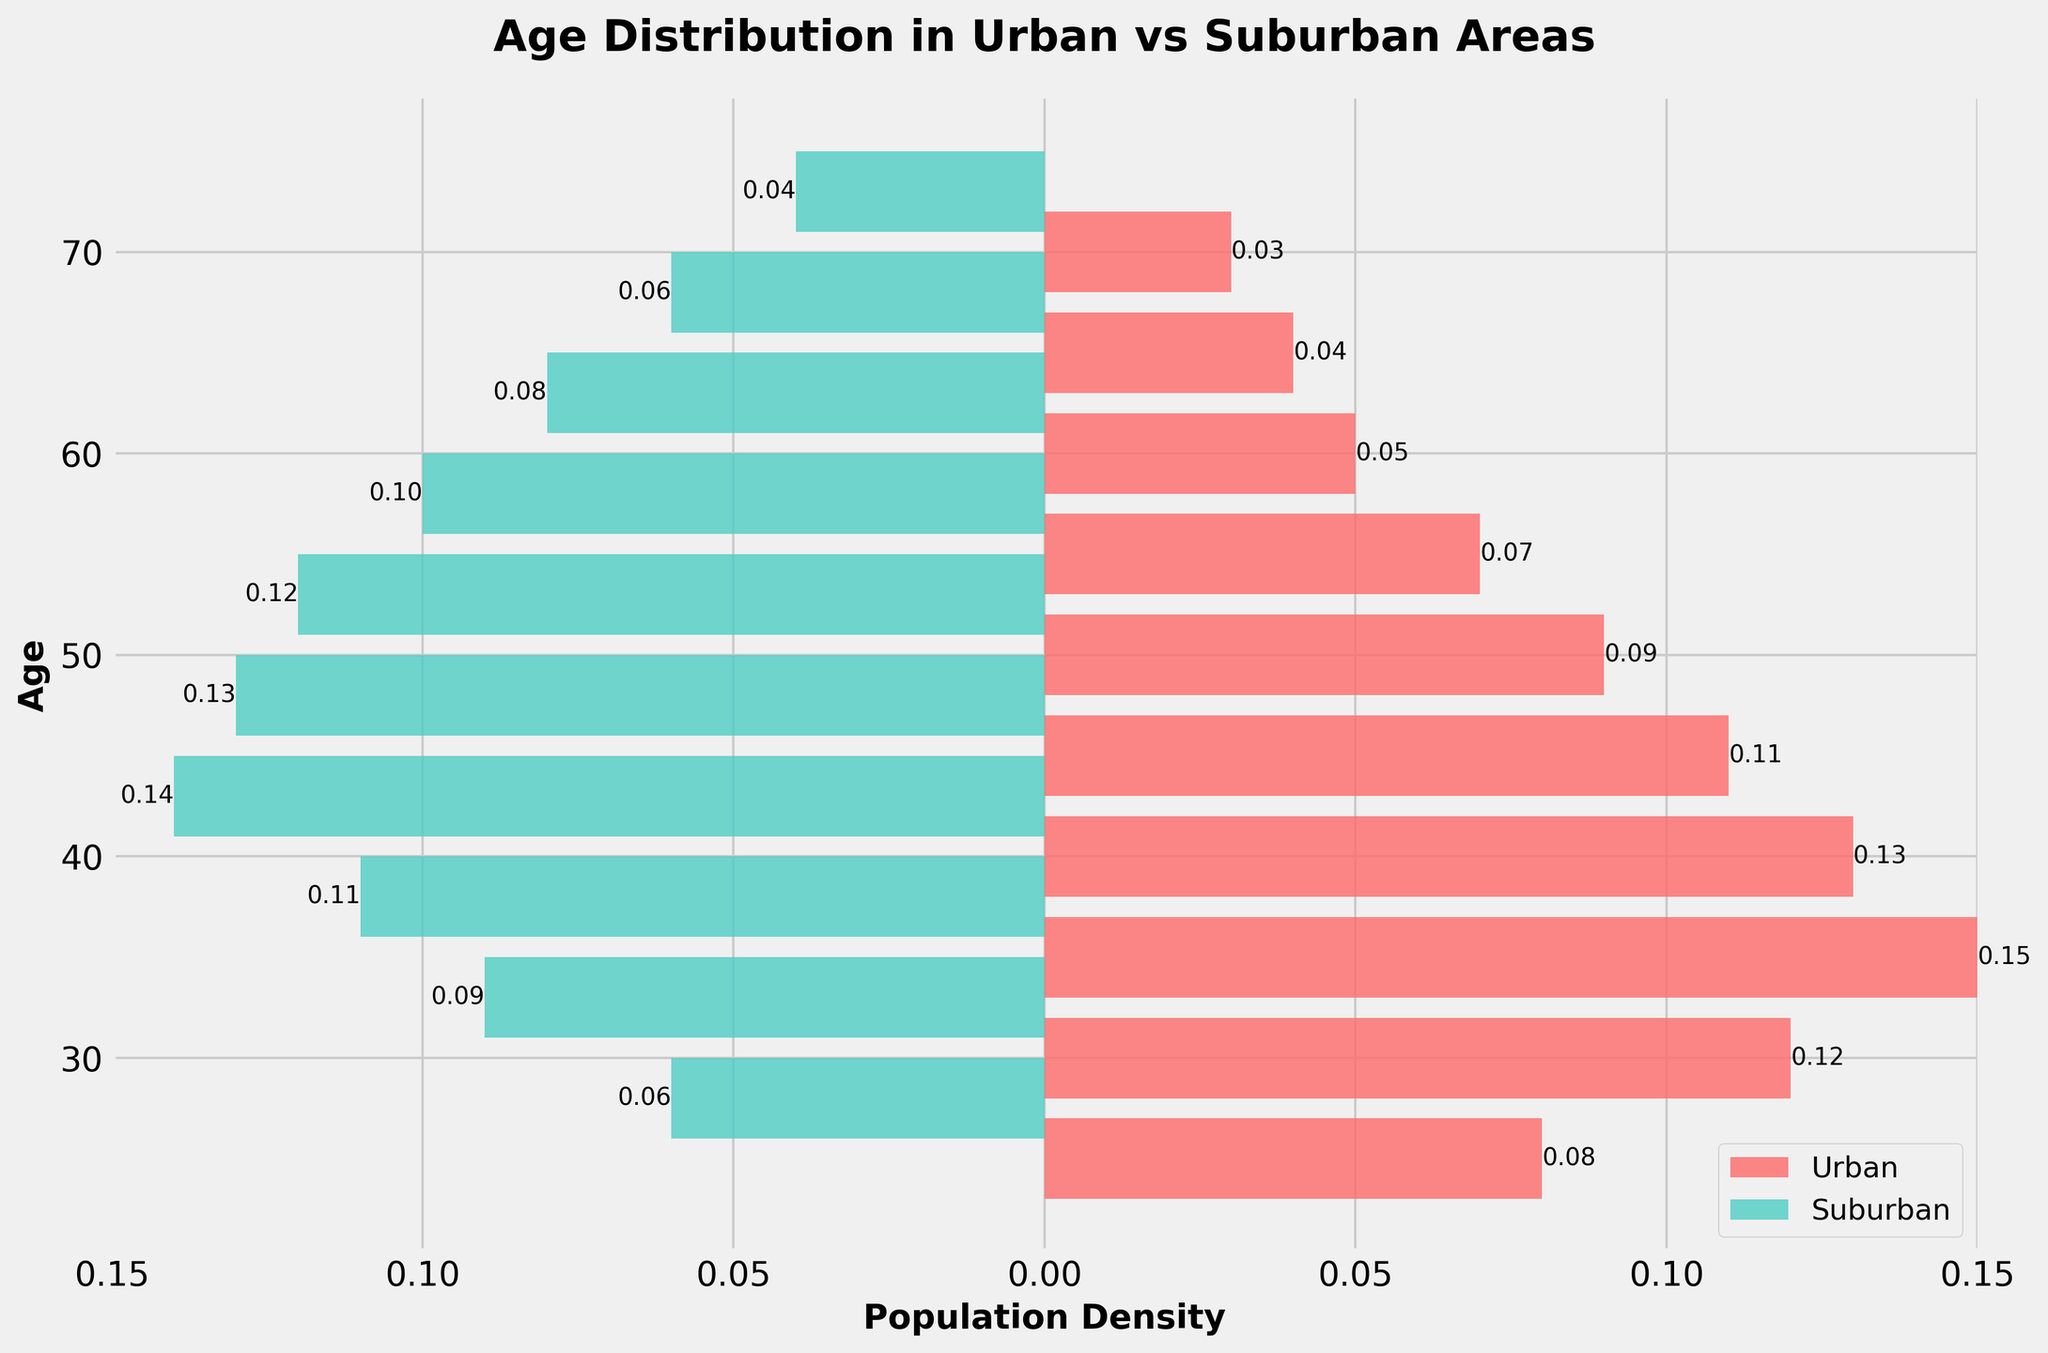What is the title of the figure? The title is usually displayed at the top of the figure and helps identify the main topic. By reading the text in the title area, you can see it says "Age Distribution in Urban vs Suburban Areas"
Answer: Age Distribution in Urban vs Suburban Areas How is the density for suburban areas represented in the plot? Suburban densities are depicted as horizontal bars extending to the left of the centerline. These bars are color-coded in a teal color and have negative density values on the left side
Answer: Horizontal bars in teal extending left At what age is the population density highest in urban areas? The highest bar for the urban area has the greatest horizontal length. By comparing the lengths, the bar at age 35 has the highest density value of 0.15
Answer: Age 35 Which area has a higher density at age 40, urban or suburban? Locate the horizontal bars for age 40 in both colors. Compare the lengths: Urban at age 40 has a bar extending 0.13 to the right, while Suburban at a similar age has a bar extending 0.14 to the left, indicating suburban is higher
Answer: Suburban What is the age range where suburban population density exceeds urban population density? Examine the horizontal lengths of bars for suburban and urban areas across different ages. Suburban density exceeds urban for ages 43 to 58 because the teal bars extend further left than the red bars extend right at those ages
Answer: 43 to 58 At age 65, how do the population densities compare between urban and suburban areas? Look at the bars corresponding to age 65. The urban density bar has a length of 0.04 extending to the right, while the suburban density bar for the same age is shorter at 0.04 extending to the left
Answer: Same What is the sum of the population densities at ages 35 and 40 in urban areas? Locate the bars for ages 35 and 40. At age 35, the density is 0.15, and at age 40, it is 0.13. The sum of these densities is 0.15 + 0.13 = 0.28
Answer: 0.28 Which age group has the lowest urban population density and what is the value? Identify the shortest bar in the urban area color. The shortest bar is at age 70 with a density value of 0.03
Answer: Age 70, 0.03 What is the average population density for suburban residents aged between 48 and 58? Measure the bars for ages 48, 53, and 58: 0.13, 0.12, and 0.10. Find the average: (0.13 + 0.12 + 0.10) / 3 = 0.35 / 3 = 0.1167
Answer: 0.12 How many major tick marks are on the x-axis, and what are their labeled values? The x-axis marks the density values increasing by 0.05. You'll see there are ticks at -0.15, -0.10, -0.05, 0, 0.05, 0.10, and 0.15
Answer: Seven ticks: 0.15, 0.10, 0.05, 0, 0.05, 0.10, 0.15 